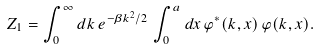<formula> <loc_0><loc_0><loc_500><loc_500>Z _ { 1 } = \int _ { 0 } ^ { \infty } d k \, e ^ { - \beta k ^ { 2 } / 2 } \, \int _ { 0 } ^ { a } d x \, \varphi ^ { * } ( k , x ) \, \varphi ( k , x ) .</formula> 